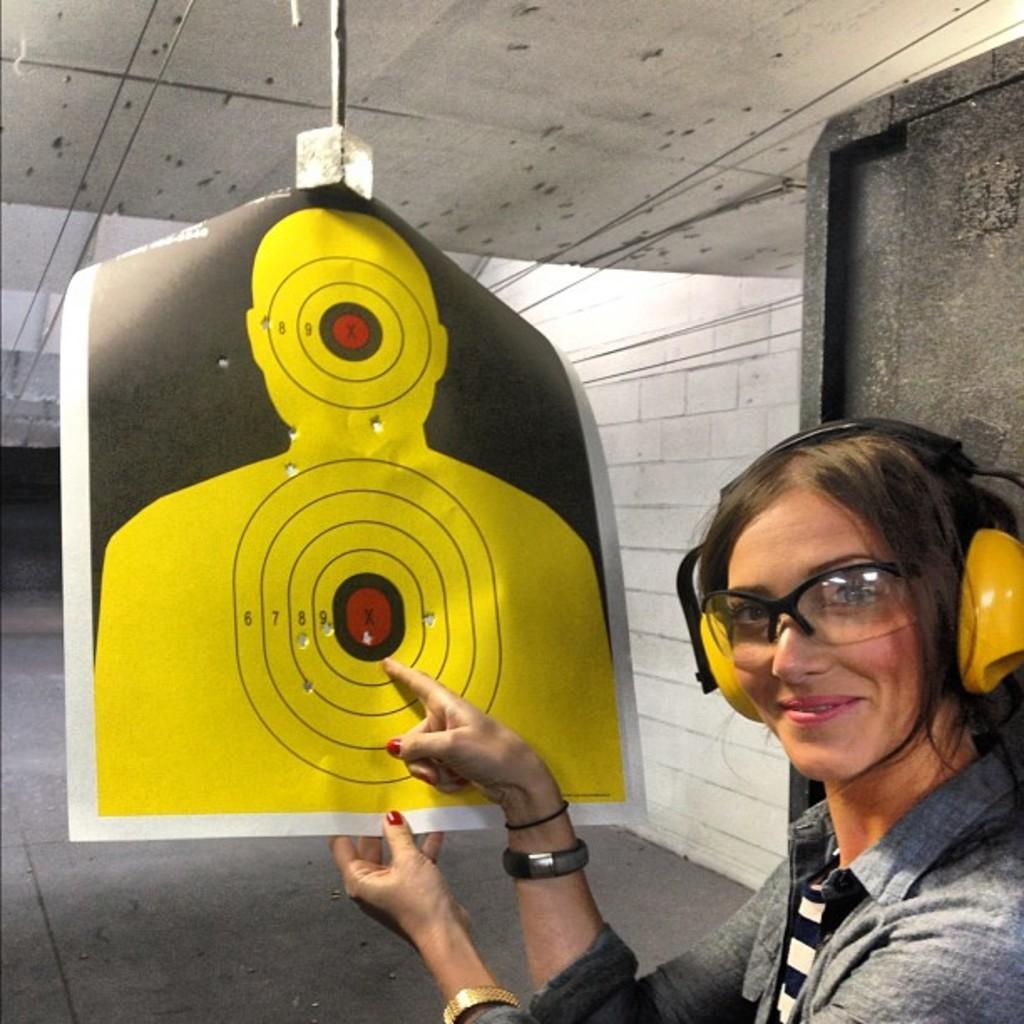In one or two sentences, can you explain what this image depicts? In this image on the right side we can see a woman and she wore a headset to her ears. In the background we can see wall, floor, wires and an object. 